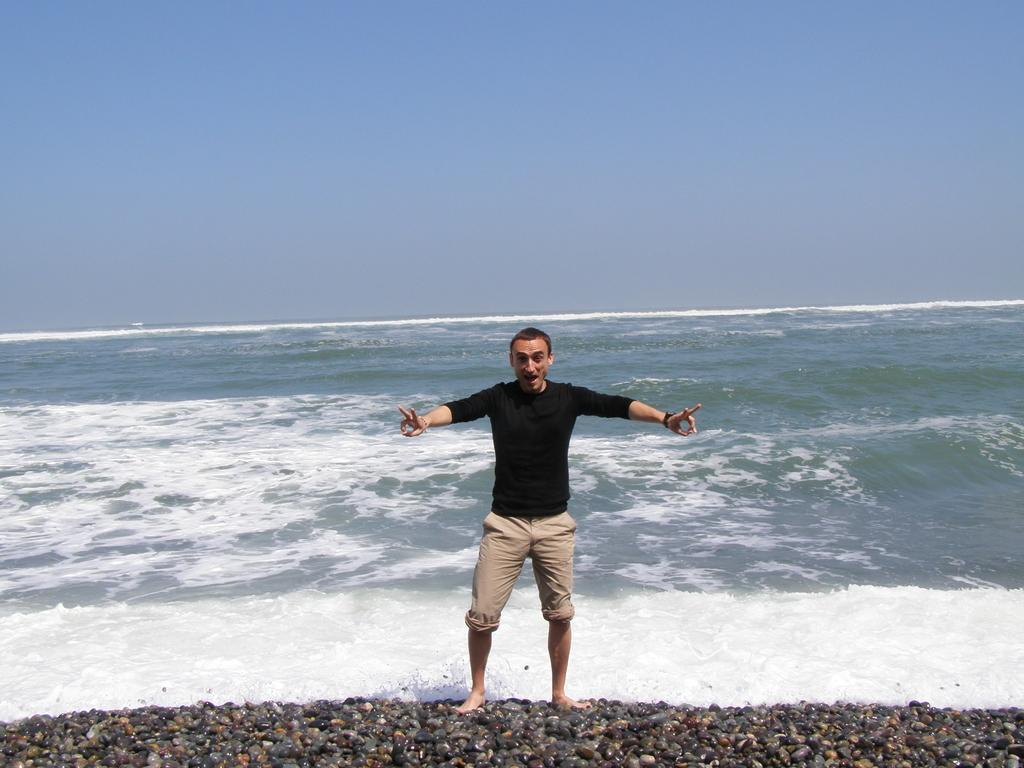What is the person in the image doing? The person is standing on stones in the image. What can be seen in the background of the image? There is an ocean and the sky visible in the background of the image. What type of flower is blooming in the ocean in the image? There are no flowers visible in the image, as it features a person standing on stones with an ocean and sky in the background. 